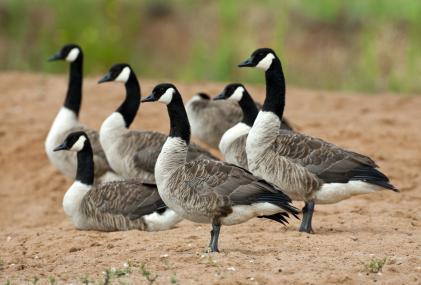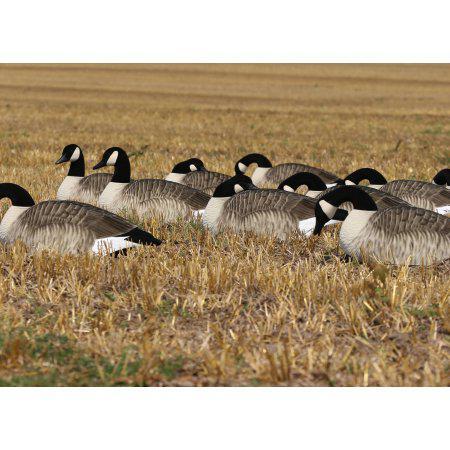The first image is the image on the left, the second image is the image on the right. For the images displayed, is the sentence "None of the birds are standing on wood or snow." factually correct? Answer yes or no. Yes. The first image is the image on the left, the second image is the image on the right. Assess this claim about the two images: "All birds are standing, and all birds are 'real' living animals.". Correct or not? Answer yes or no. No. 